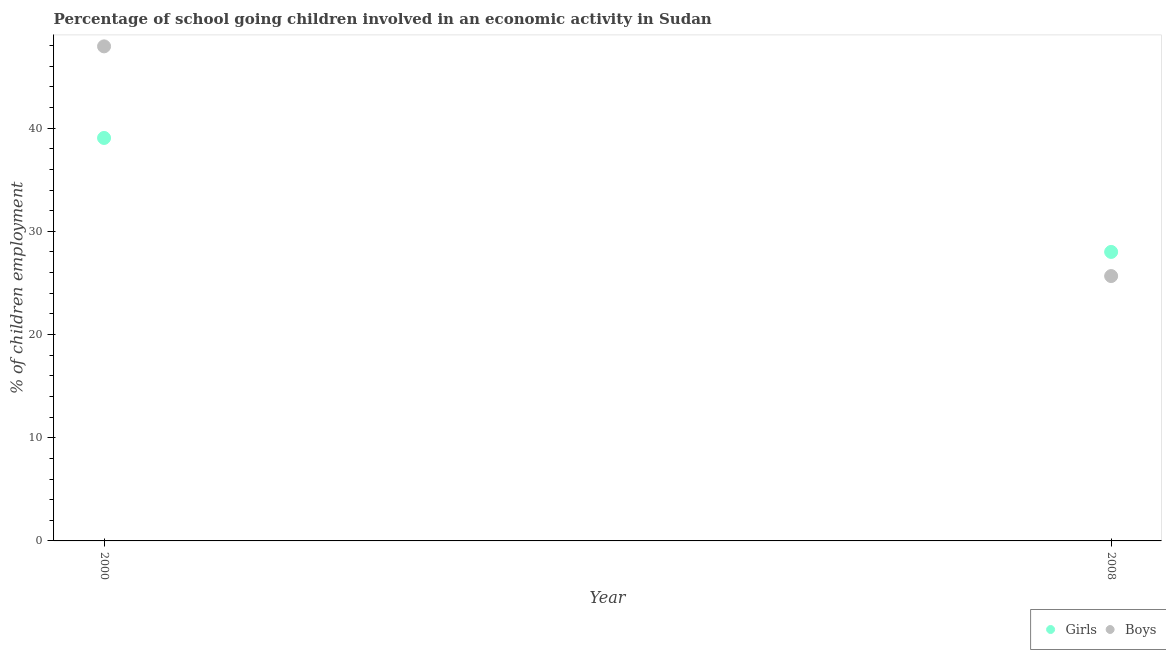Is the number of dotlines equal to the number of legend labels?
Keep it short and to the point. Yes. What is the percentage of school going boys in 2008?
Your answer should be compact. 25.67. Across all years, what is the maximum percentage of school going boys?
Your answer should be compact. 47.92. Across all years, what is the minimum percentage of school going girls?
Your answer should be very brief. 28. What is the total percentage of school going girls in the graph?
Offer a terse response. 67.05. What is the difference between the percentage of school going girls in 2000 and that in 2008?
Give a very brief answer. 11.04. What is the difference between the percentage of school going girls in 2000 and the percentage of school going boys in 2008?
Offer a terse response. 13.38. What is the average percentage of school going girls per year?
Your response must be concise. 33.52. In the year 2000, what is the difference between the percentage of school going boys and percentage of school going girls?
Give a very brief answer. 8.88. What is the ratio of the percentage of school going boys in 2000 to that in 2008?
Offer a terse response. 1.87. Is the percentage of school going boys in 2000 less than that in 2008?
Provide a short and direct response. No. In how many years, is the percentage of school going girls greater than the average percentage of school going girls taken over all years?
Give a very brief answer. 1. Is the percentage of school going boys strictly greater than the percentage of school going girls over the years?
Your answer should be compact. No. Is the percentage of school going girls strictly less than the percentage of school going boys over the years?
Offer a very short reply. No. How many dotlines are there?
Ensure brevity in your answer.  2. Does the graph contain grids?
Provide a short and direct response. No. What is the title of the graph?
Ensure brevity in your answer.  Percentage of school going children involved in an economic activity in Sudan. Does "2012 US$" appear as one of the legend labels in the graph?
Keep it short and to the point. No. What is the label or title of the X-axis?
Your response must be concise. Year. What is the label or title of the Y-axis?
Give a very brief answer. % of children employment. What is the % of children employment in Girls in 2000?
Provide a succinct answer. 39.05. What is the % of children employment in Boys in 2000?
Your answer should be compact. 47.92. What is the % of children employment in Girls in 2008?
Offer a very short reply. 28. What is the % of children employment in Boys in 2008?
Ensure brevity in your answer.  25.67. Across all years, what is the maximum % of children employment of Girls?
Keep it short and to the point. 39.05. Across all years, what is the maximum % of children employment of Boys?
Ensure brevity in your answer.  47.92. Across all years, what is the minimum % of children employment of Girls?
Make the answer very short. 28. Across all years, what is the minimum % of children employment of Boys?
Your answer should be compact. 25.67. What is the total % of children employment of Girls in the graph?
Offer a very short reply. 67.05. What is the total % of children employment of Boys in the graph?
Your answer should be compact. 73.59. What is the difference between the % of children employment in Girls in 2000 and that in 2008?
Your response must be concise. 11.04. What is the difference between the % of children employment in Boys in 2000 and that in 2008?
Give a very brief answer. 22.26. What is the difference between the % of children employment of Girls in 2000 and the % of children employment of Boys in 2008?
Give a very brief answer. 13.38. What is the average % of children employment of Girls per year?
Provide a succinct answer. 33.52. What is the average % of children employment in Boys per year?
Ensure brevity in your answer.  36.79. In the year 2000, what is the difference between the % of children employment in Girls and % of children employment in Boys?
Keep it short and to the point. -8.88. In the year 2008, what is the difference between the % of children employment of Girls and % of children employment of Boys?
Your answer should be compact. 2.34. What is the ratio of the % of children employment of Girls in 2000 to that in 2008?
Give a very brief answer. 1.39. What is the ratio of the % of children employment of Boys in 2000 to that in 2008?
Provide a short and direct response. 1.87. What is the difference between the highest and the second highest % of children employment of Girls?
Your response must be concise. 11.04. What is the difference between the highest and the second highest % of children employment of Boys?
Your response must be concise. 22.26. What is the difference between the highest and the lowest % of children employment of Girls?
Provide a succinct answer. 11.04. What is the difference between the highest and the lowest % of children employment in Boys?
Make the answer very short. 22.26. 